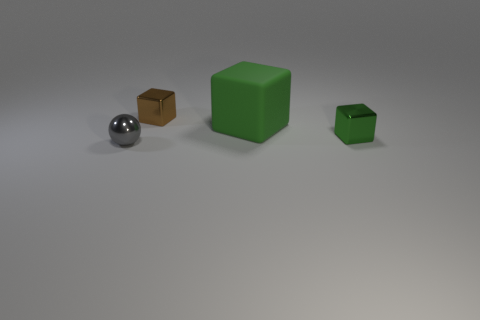Is there a matte thing that has the same size as the green metallic cube?
Provide a succinct answer. No. What material is the small object that is in front of the tiny block that is in front of the tiny brown metallic cube?
Provide a short and direct response. Metal. What number of other metallic spheres have the same color as the small sphere?
Make the answer very short. 0. There is a green object that is the same material as the brown object; what shape is it?
Offer a terse response. Cube. There is a shiny thing to the right of the brown cube; how big is it?
Your answer should be very brief. Small. Is the number of large green rubber blocks that are on the right side of the green matte object the same as the number of green things that are on the left side of the green metal object?
Ensure brevity in your answer.  No. The tiny object behind the metal block that is in front of the small metal cube left of the small green thing is what color?
Your answer should be compact. Brown. What number of shiny things are in front of the brown thing and behind the small gray ball?
Keep it short and to the point. 1. Do the small shiny block behind the big green matte object and the metallic object that is on the right side of the large green block have the same color?
Provide a short and direct response. No. Is there anything else that has the same material as the small brown thing?
Make the answer very short. Yes. 